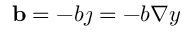<formula> <loc_0><loc_0><loc_500><loc_500>b = - b \jmath = - b \nabla y</formula> 